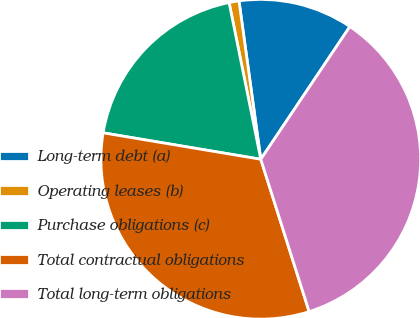<chart> <loc_0><loc_0><loc_500><loc_500><pie_chart><fcel>Long-term debt (a)<fcel>Operating leases (b)<fcel>Purchase obligations (c)<fcel>Total contractual obligations<fcel>Total long-term obligations<nl><fcel>11.59%<fcel>1.0%<fcel>19.18%<fcel>32.54%<fcel>35.7%<nl></chart> 